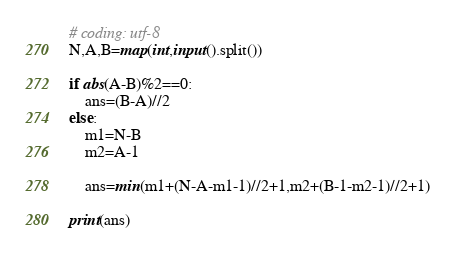<code> <loc_0><loc_0><loc_500><loc_500><_Python_># coding: utf-8
N,A,B=map(int,input().split())

if abs(A-B)%2==0:
    ans=(B-A)//2
else:
    m1=N-B
    m2=A-1
    
    ans=min(m1+(N-A-m1-1)//2+1,m2+(B-1-m2-1)//2+1)

print(ans)

</code> 